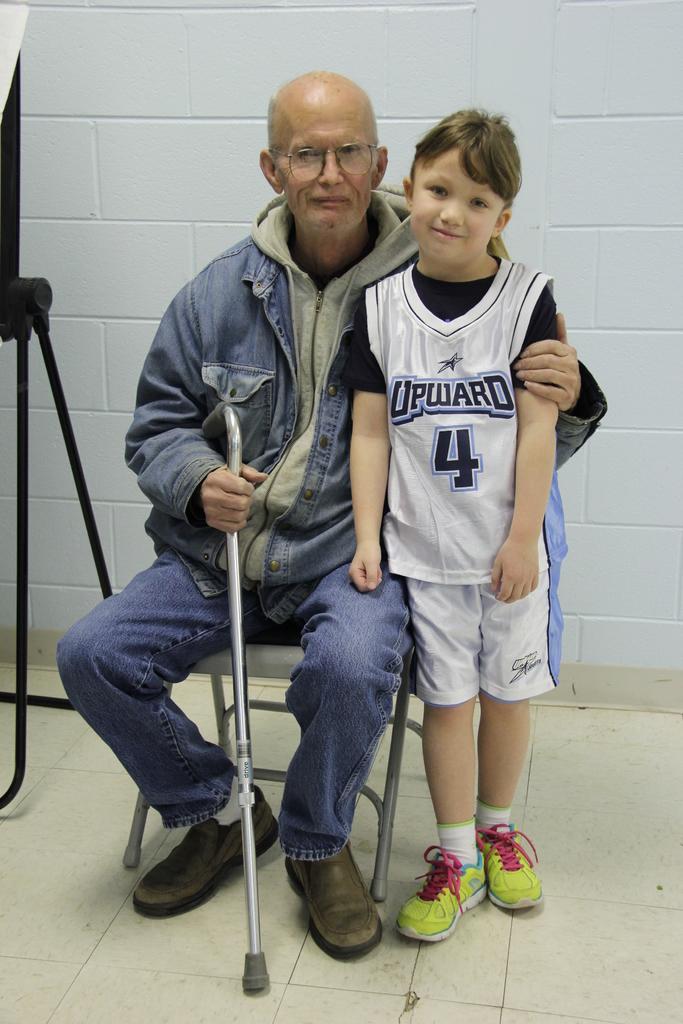What is the number on the child basketball shirt?
Offer a terse response. 4. What team does the boy play for?
Ensure brevity in your answer.  Upward. 